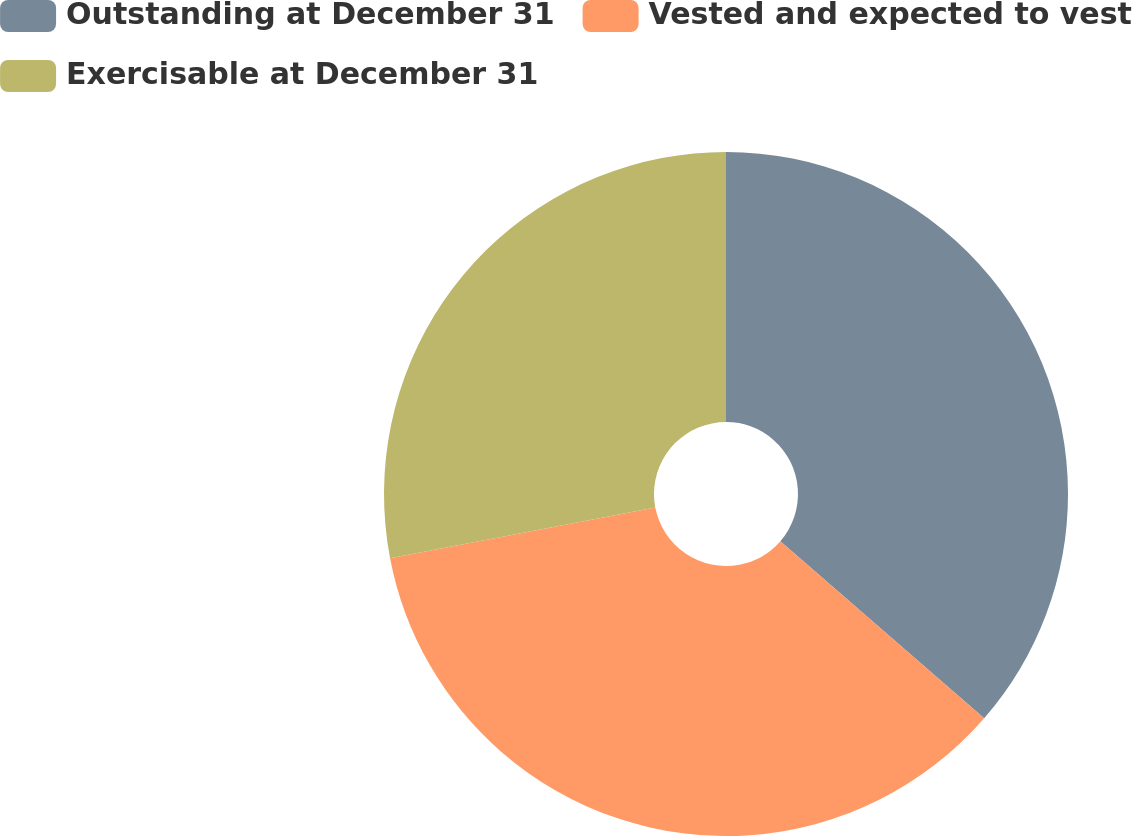Convert chart. <chart><loc_0><loc_0><loc_500><loc_500><pie_chart><fcel>Outstanding at December 31<fcel>Vested and expected to vest<fcel>Exercisable at December 31<nl><fcel>36.38%<fcel>35.61%<fcel>28.0%<nl></chart> 